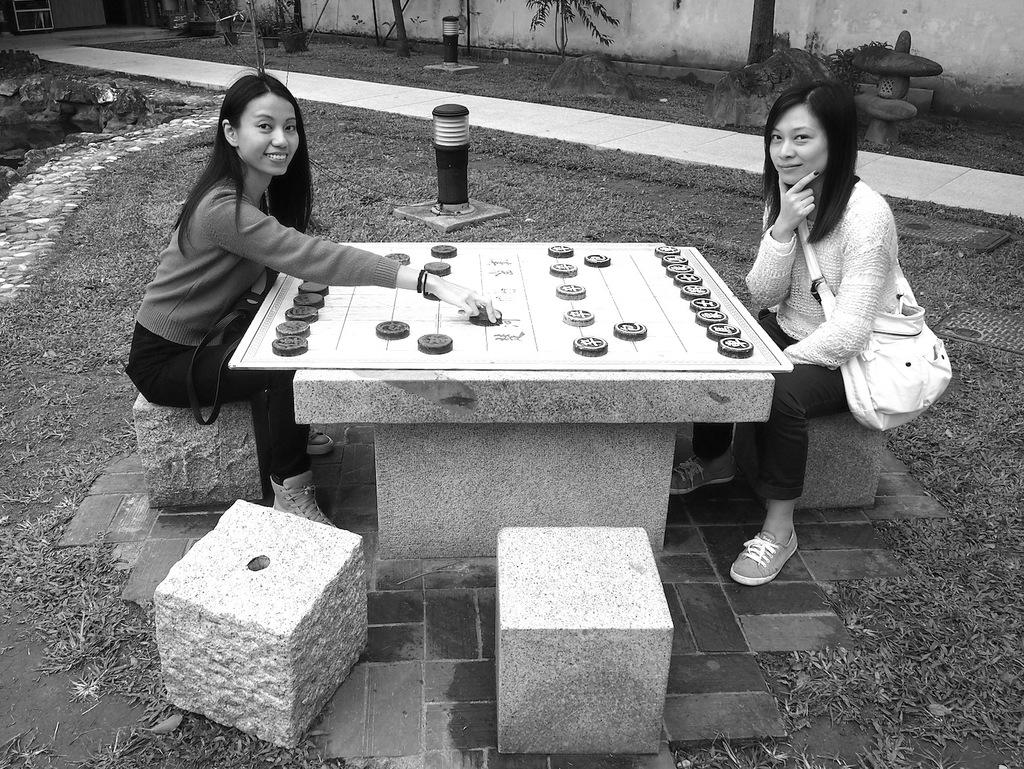How many people are in the image? There are two women in the image. What are the women doing in the image? The women are sitting on a rock and playing a game. Where is the game located in relation to the women? The game is in front of them. What type of stove can be seen in the image? There is no stove present in the image. Can you tell me the name of the mom in the image? There is no mention of a mom or any specific individuals in the image. 